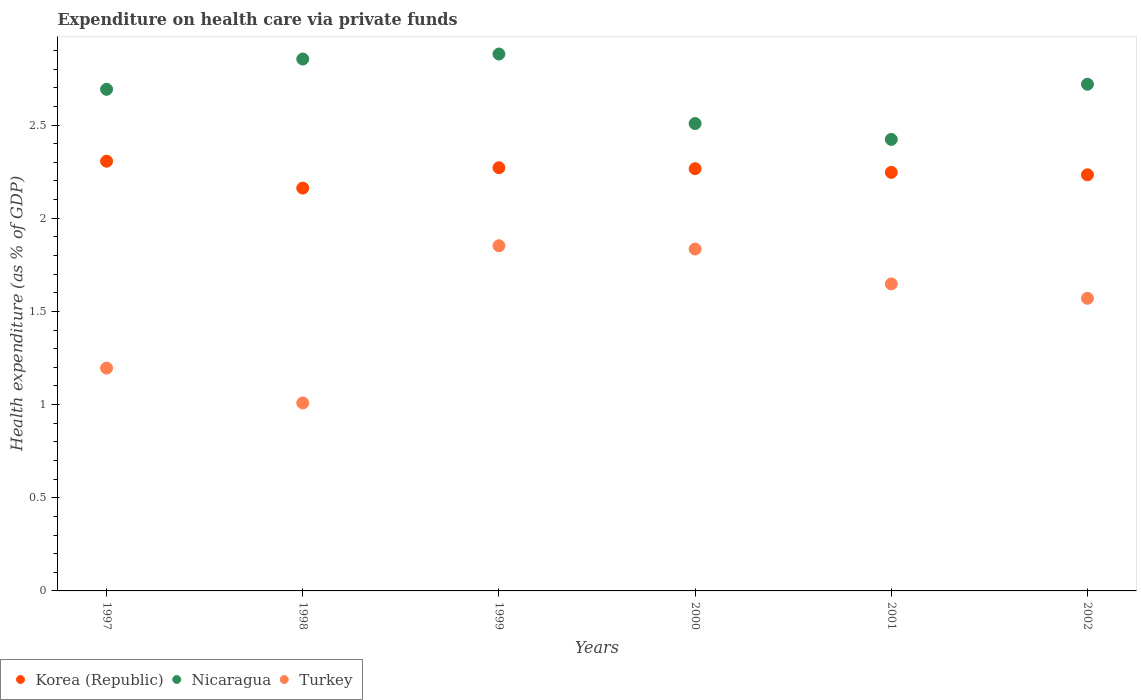Is the number of dotlines equal to the number of legend labels?
Offer a very short reply. Yes. What is the expenditure made on health care in Nicaragua in 2001?
Make the answer very short. 2.42. Across all years, what is the maximum expenditure made on health care in Korea (Republic)?
Your answer should be very brief. 2.31. Across all years, what is the minimum expenditure made on health care in Korea (Republic)?
Provide a succinct answer. 2.16. In which year was the expenditure made on health care in Turkey maximum?
Your answer should be very brief. 1999. What is the total expenditure made on health care in Nicaragua in the graph?
Make the answer very short. 16.08. What is the difference between the expenditure made on health care in Nicaragua in 1998 and that in 2002?
Give a very brief answer. 0.14. What is the difference between the expenditure made on health care in Korea (Republic) in 1999 and the expenditure made on health care in Turkey in 2000?
Your response must be concise. 0.44. What is the average expenditure made on health care in Turkey per year?
Make the answer very short. 1.52. In the year 1999, what is the difference between the expenditure made on health care in Korea (Republic) and expenditure made on health care in Turkey?
Your answer should be compact. 0.42. What is the ratio of the expenditure made on health care in Korea (Republic) in 1999 to that in 2002?
Your answer should be compact. 1.02. Is the expenditure made on health care in Nicaragua in 1999 less than that in 2000?
Your answer should be compact. No. Is the difference between the expenditure made on health care in Korea (Republic) in 2000 and 2001 greater than the difference between the expenditure made on health care in Turkey in 2000 and 2001?
Provide a short and direct response. No. What is the difference between the highest and the second highest expenditure made on health care in Turkey?
Offer a very short reply. 0.02. What is the difference between the highest and the lowest expenditure made on health care in Nicaragua?
Ensure brevity in your answer.  0.46. Is the sum of the expenditure made on health care in Nicaragua in 1997 and 2002 greater than the maximum expenditure made on health care in Turkey across all years?
Ensure brevity in your answer.  Yes. Is it the case that in every year, the sum of the expenditure made on health care in Korea (Republic) and expenditure made on health care in Nicaragua  is greater than the expenditure made on health care in Turkey?
Your answer should be compact. Yes. Does the expenditure made on health care in Nicaragua monotonically increase over the years?
Your response must be concise. No. How many dotlines are there?
Your answer should be very brief. 3. How many years are there in the graph?
Make the answer very short. 6. Does the graph contain any zero values?
Keep it short and to the point. No. Does the graph contain grids?
Give a very brief answer. No. What is the title of the graph?
Provide a short and direct response. Expenditure on health care via private funds. Does "Latin America(all income levels)" appear as one of the legend labels in the graph?
Provide a succinct answer. No. What is the label or title of the X-axis?
Provide a succinct answer. Years. What is the label or title of the Y-axis?
Offer a terse response. Health expenditure (as % of GDP). What is the Health expenditure (as % of GDP) in Korea (Republic) in 1997?
Offer a terse response. 2.31. What is the Health expenditure (as % of GDP) of Nicaragua in 1997?
Your answer should be compact. 2.69. What is the Health expenditure (as % of GDP) of Turkey in 1997?
Give a very brief answer. 1.2. What is the Health expenditure (as % of GDP) in Korea (Republic) in 1998?
Offer a very short reply. 2.16. What is the Health expenditure (as % of GDP) in Nicaragua in 1998?
Keep it short and to the point. 2.85. What is the Health expenditure (as % of GDP) in Turkey in 1998?
Keep it short and to the point. 1.01. What is the Health expenditure (as % of GDP) of Korea (Republic) in 1999?
Provide a short and direct response. 2.27. What is the Health expenditure (as % of GDP) in Nicaragua in 1999?
Your response must be concise. 2.88. What is the Health expenditure (as % of GDP) of Turkey in 1999?
Make the answer very short. 1.85. What is the Health expenditure (as % of GDP) in Korea (Republic) in 2000?
Keep it short and to the point. 2.27. What is the Health expenditure (as % of GDP) of Nicaragua in 2000?
Your response must be concise. 2.51. What is the Health expenditure (as % of GDP) in Turkey in 2000?
Provide a short and direct response. 1.83. What is the Health expenditure (as % of GDP) in Korea (Republic) in 2001?
Provide a short and direct response. 2.25. What is the Health expenditure (as % of GDP) in Nicaragua in 2001?
Provide a succinct answer. 2.42. What is the Health expenditure (as % of GDP) in Turkey in 2001?
Provide a short and direct response. 1.65. What is the Health expenditure (as % of GDP) in Korea (Republic) in 2002?
Make the answer very short. 2.23. What is the Health expenditure (as % of GDP) of Nicaragua in 2002?
Your answer should be very brief. 2.72. What is the Health expenditure (as % of GDP) of Turkey in 2002?
Make the answer very short. 1.57. Across all years, what is the maximum Health expenditure (as % of GDP) in Korea (Republic)?
Provide a succinct answer. 2.31. Across all years, what is the maximum Health expenditure (as % of GDP) in Nicaragua?
Your answer should be compact. 2.88. Across all years, what is the maximum Health expenditure (as % of GDP) of Turkey?
Your response must be concise. 1.85. Across all years, what is the minimum Health expenditure (as % of GDP) of Korea (Republic)?
Ensure brevity in your answer.  2.16. Across all years, what is the minimum Health expenditure (as % of GDP) of Nicaragua?
Offer a terse response. 2.42. Across all years, what is the minimum Health expenditure (as % of GDP) of Turkey?
Offer a terse response. 1.01. What is the total Health expenditure (as % of GDP) of Korea (Republic) in the graph?
Your response must be concise. 13.48. What is the total Health expenditure (as % of GDP) in Nicaragua in the graph?
Keep it short and to the point. 16.08. What is the total Health expenditure (as % of GDP) in Turkey in the graph?
Keep it short and to the point. 9.11. What is the difference between the Health expenditure (as % of GDP) of Korea (Republic) in 1997 and that in 1998?
Your answer should be compact. 0.14. What is the difference between the Health expenditure (as % of GDP) in Nicaragua in 1997 and that in 1998?
Offer a terse response. -0.16. What is the difference between the Health expenditure (as % of GDP) in Turkey in 1997 and that in 1998?
Make the answer very short. 0.19. What is the difference between the Health expenditure (as % of GDP) in Korea (Republic) in 1997 and that in 1999?
Provide a succinct answer. 0.04. What is the difference between the Health expenditure (as % of GDP) of Nicaragua in 1997 and that in 1999?
Your answer should be very brief. -0.19. What is the difference between the Health expenditure (as % of GDP) of Turkey in 1997 and that in 1999?
Offer a very short reply. -0.66. What is the difference between the Health expenditure (as % of GDP) in Korea (Republic) in 1997 and that in 2000?
Provide a short and direct response. 0.04. What is the difference between the Health expenditure (as % of GDP) in Nicaragua in 1997 and that in 2000?
Make the answer very short. 0.18. What is the difference between the Health expenditure (as % of GDP) of Turkey in 1997 and that in 2000?
Your response must be concise. -0.64. What is the difference between the Health expenditure (as % of GDP) of Korea (Republic) in 1997 and that in 2001?
Ensure brevity in your answer.  0.06. What is the difference between the Health expenditure (as % of GDP) of Nicaragua in 1997 and that in 2001?
Provide a short and direct response. 0.27. What is the difference between the Health expenditure (as % of GDP) in Turkey in 1997 and that in 2001?
Your answer should be very brief. -0.45. What is the difference between the Health expenditure (as % of GDP) of Korea (Republic) in 1997 and that in 2002?
Provide a short and direct response. 0.07. What is the difference between the Health expenditure (as % of GDP) in Nicaragua in 1997 and that in 2002?
Give a very brief answer. -0.03. What is the difference between the Health expenditure (as % of GDP) of Turkey in 1997 and that in 2002?
Your answer should be very brief. -0.37. What is the difference between the Health expenditure (as % of GDP) of Korea (Republic) in 1998 and that in 1999?
Ensure brevity in your answer.  -0.11. What is the difference between the Health expenditure (as % of GDP) in Nicaragua in 1998 and that in 1999?
Keep it short and to the point. -0.03. What is the difference between the Health expenditure (as % of GDP) of Turkey in 1998 and that in 1999?
Provide a succinct answer. -0.84. What is the difference between the Health expenditure (as % of GDP) in Korea (Republic) in 1998 and that in 2000?
Your answer should be compact. -0.1. What is the difference between the Health expenditure (as % of GDP) in Nicaragua in 1998 and that in 2000?
Make the answer very short. 0.35. What is the difference between the Health expenditure (as % of GDP) of Turkey in 1998 and that in 2000?
Keep it short and to the point. -0.83. What is the difference between the Health expenditure (as % of GDP) in Korea (Republic) in 1998 and that in 2001?
Your response must be concise. -0.08. What is the difference between the Health expenditure (as % of GDP) in Nicaragua in 1998 and that in 2001?
Provide a short and direct response. 0.43. What is the difference between the Health expenditure (as % of GDP) of Turkey in 1998 and that in 2001?
Give a very brief answer. -0.64. What is the difference between the Health expenditure (as % of GDP) of Korea (Republic) in 1998 and that in 2002?
Your answer should be very brief. -0.07. What is the difference between the Health expenditure (as % of GDP) in Nicaragua in 1998 and that in 2002?
Provide a short and direct response. 0.14. What is the difference between the Health expenditure (as % of GDP) of Turkey in 1998 and that in 2002?
Provide a succinct answer. -0.56. What is the difference between the Health expenditure (as % of GDP) of Korea (Republic) in 1999 and that in 2000?
Offer a terse response. 0.01. What is the difference between the Health expenditure (as % of GDP) of Nicaragua in 1999 and that in 2000?
Make the answer very short. 0.37. What is the difference between the Health expenditure (as % of GDP) of Turkey in 1999 and that in 2000?
Provide a succinct answer. 0.02. What is the difference between the Health expenditure (as % of GDP) of Korea (Republic) in 1999 and that in 2001?
Your response must be concise. 0.02. What is the difference between the Health expenditure (as % of GDP) of Nicaragua in 1999 and that in 2001?
Provide a short and direct response. 0.46. What is the difference between the Health expenditure (as % of GDP) in Turkey in 1999 and that in 2001?
Give a very brief answer. 0.2. What is the difference between the Health expenditure (as % of GDP) in Korea (Republic) in 1999 and that in 2002?
Make the answer very short. 0.04. What is the difference between the Health expenditure (as % of GDP) of Nicaragua in 1999 and that in 2002?
Provide a short and direct response. 0.16. What is the difference between the Health expenditure (as % of GDP) in Turkey in 1999 and that in 2002?
Your answer should be compact. 0.28. What is the difference between the Health expenditure (as % of GDP) in Korea (Republic) in 2000 and that in 2001?
Make the answer very short. 0.02. What is the difference between the Health expenditure (as % of GDP) in Nicaragua in 2000 and that in 2001?
Your answer should be very brief. 0.09. What is the difference between the Health expenditure (as % of GDP) of Turkey in 2000 and that in 2001?
Provide a short and direct response. 0.19. What is the difference between the Health expenditure (as % of GDP) of Korea (Republic) in 2000 and that in 2002?
Provide a short and direct response. 0.03. What is the difference between the Health expenditure (as % of GDP) in Nicaragua in 2000 and that in 2002?
Offer a very short reply. -0.21. What is the difference between the Health expenditure (as % of GDP) in Turkey in 2000 and that in 2002?
Provide a short and direct response. 0.26. What is the difference between the Health expenditure (as % of GDP) of Korea (Republic) in 2001 and that in 2002?
Ensure brevity in your answer.  0.01. What is the difference between the Health expenditure (as % of GDP) in Nicaragua in 2001 and that in 2002?
Offer a terse response. -0.3. What is the difference between the Health expenditure (as % of GDP) in Turkey in 2001 and that in 2002?
Your answer should be compact. 0.08. What is the difference between the Health expenditure (as % of GDP) of Korea (Republic) in 1997 and the Health expenditure (as % of GDP) of Nicaragua in 1998?
Your answer should be very brief. -0.55. What is the difference between the Health expenditure (as % of GDP) of Korea (Republic) in 1997 and the Health expenditure (as % of GDP) of Turkey in 1998?
Give a very brief answer. 1.3. What is the difference between the Health expenditure (as % of GDP) of Nicaragua in 1997 and the Health expenditure (as % of GDP) of Turkey in 1998?
Offer a very short reply. 1.68. What is the difference between the Health expenditure (as % of GDP) of Korea (Republic) in 1997 and the Health expenditure (as % of GDP) of Nicaragua in 1999?
Keep it short and to the point. -0.58. What is the difference between the Health expenditure (as % of GDP) in Korea (Republic) in 1997 and the Health expenditure (as % of GDP) in Turkey in 1999?
Provide a short and direct response. 0.45. What is the difference between the Health expenditure (as % of GDP) in Nicaragua in 1997 and the Health expenditure (as % of GDP) in Turkey in 1999?
Give a very brief answer. 0.84. What is the difference between the Health expenditure (as % of GDP) of Korea (Republic) in 1997 and the Health expenditure (as % of GDP) of Nicaragua in 2000?
Your answer should be compact. -0.2. What is the difference between the Health expenditure (as % of GDP) in Korea (Republic) in 1997 and the Health expenditure (as % of GDP) in Turkey in 2000?
Provide a short and direct response. 0.47. What is the difference between the Health expenditure (as % of GDP) of Nicaragua in 1997 and the Health expenditure (as % of GDP) of Turkey in 2000?
Your answer should be very brief. 0.86. What is the difference between the Health expenditure (as % of GDP) in Korea (Republic) in 1997 and the Health expenditure (as % of GDP) in Nicaragua in 2001?
Your answer should be very brief. -0.12. What is the difference between the Health expenditure (as % of GDP) of Korea (Republic) in 1997 and the Health expenditure (as % of GDP) of Turkey in 2001?
Offer a very short reply. 0.66. What is the difference between the Health expenditure (as % of GDP) of Nicaragua in 1997 and the Health expenditure (as % of GDP) of Turkey in 2001?
Make the answer very short. 1.04. What is the difference between the Health expenditure (as % of GDP) in Korea (Republic) in 1997 and the Health expenditure (as % of GDP) in Nicaragua in 2002?
Provide a short and direct response. -0.41. What is the difference between the Health expenditure (as % of GDP) in Korea (Republic) in 1997 and the Health expenditure (as % of GDP) in Turkey in 2002?
Your answer should be very brief. 0.74. What is the difference between the Health expenditure (as % of GDP) in Nicaragua in 1997 and the Health expenditure (as % of GDP) in Turkey in 2002?
Make the answer very short. 1.12. What is the difference between the Health expenditure (as % of GDP) in Korea (Republic) in 1998 and the Health expenditure (as % of GDP) in Nicaragua in 1999?
Ensure brevity in your answer.  -0.72. What is the difference between the Health expenditure (as % of GDP) of Korea (Republic) in 1998 and the Health expenditure (as % of GDP) of Turkey in 1999?
Provide a succinct answer. 0.31. What is the difference between the Health expenditure (as % of GDP) in Nicaragua in 1998 and the Health expenditure (as % of GDP) in Turkey in 1999?
Keep it short and to the point. 1. What is the difference between the Health expenditure (as % of GDP) of Korea (Republic) in 1998 and the Health expenditure (as % of GDP) of Nicaragua in 2000?
Ensure brevity in your answer.  -0.35. What is the difference between the Health expenditure (as % of GDP) of Korea (Republic) in 1998 and the Health expenditure (as % of GDP) of Turkey in 2000?
Offer a terse response. 0.33. What is the difference between the Health expenditure (as % of GDP) of Nicaragua in 1998 and the Health expenditure (as % of GDP) of Turkey in 2000?
Give a very brief answer. 1.02. What is the difference between the Health expenditure (as % of GDP) in Korea (Republic) in 1998 and the Health expenditure (as % of GDP) in Nicaragua in 2001?
Provide a short and direct response. -0.26. What is the difference between the Health expenditure (as % of GDP) of Korea (Republic) in 1998 and the Health expenditure (as % of GDP) of Turkey in 2001?
Keep it short and to the point. 0.51. What is the difference between the Health expenditure (as % of GDP) of Nicaragua in 1998 and the Health expenditure (as % of GDP) of Turkey in 2001?
Your answer should be very brief. 1.21. What is the difference between the Health expenditure (as % of GDP) in Korea (Republic) in 1998 and the Health expenditure (as % of GDP) in Nicaragua in 2002?
Provide a short and direct response. -0.56. What is the difference between the Health expenditure (as % of GDP) in Korea (Republic) in 1998 and the Health expenditure (as % of GDP) in Turkey in 2002?
Offer a terse response. 0.59. What is the difference between the Health expenditure (as % of GDP) in Nicaragua in 1998 and the Health expenditure (as % of GDP) in Turkey in 2002?
Your answer should be very brief. 1.28. What is the difference between the Health expenditure (as % of GDP) in Korea (Republic) in 1999 and the Health expenditure (as % of GDP) in Nicaragua in 2000?
Give a very brief answer. -0.24. What is the difference between the Health expenditure (as % of GDP) of Korea (Republic) in 1999 and the Health expenditure (as % of GDP) of Turkey in 2000?
Make the answer very short. 0.44. What is the difference between the Health expenditure (as % of GDP) of Nicaragua in 1999 and the Health expenditure (as % of GDP) of Turkey in 2000?
Ensure brevity in your answer.  1.05. What is the difference between the Health expenditure (as % of GDP) in Korea (Republic) in 1999 and the Health expenditure (as % of GDP) in Nicaragua in 2001?
Provide a short and direct response. -0.15. What is the difference between the Health expenditure (as % of GDP) of Korea (Republic) in 1999 and the Health expenditure (as % of GDP) of Turkey in 2001?
Provide a short and direct response. 0.62. What is the difference between the Health expenditure (as % of GDP) in Nicaragua in 1999 and the Health expenditure (as % of GDP) in Turkey in 2001?
Make the answer very short. 1.23. What is the difference between the Health expenditure (as % of GDP) of Korea (Republic) in 1999 and the Health expenditure (as % of GDP) of Nicaragua in 2002?
Give a very brief answer. -0.45. What is the difference between the Health expenditure (as % of GDP) in Korea (Republic) in 1999 and the Health expenditure (as % of GDP) in Turkey in 2002?
Keep it short and to the point. 0.7. What is the difference between the Health expenditure (as % of GDP) of Nicaragua in 1999 and the Health expenditure (as % of GDP) of Turkey in 2002?
Your response must be concise. 1.31. What is the difference between the Health expenditure (as % of GDP) of Korea (Republic) in 2000 and the Health expenditure (as % of GDP) of Nicaragua in 2001?
Give a very brief answer. -0.16. What is the difference between the Health expenditure (as % of GDP) of Korea (Republic) in 2000 and the Health expenditure (as % of GDP) of Turkey in 2001?
Provide a succinct answer. 0.62. What is the difference between the Health expenditure (as % of GDP) of Nicaragua in 2000 and the Health expenditure (as % of GDP) of Turkey in 2001?
Ensure brevity in your answer.  0.86. What is the difference between the Health expenditure (as % of GDP) in Korea (Republic) in 2000 and the Health expenditure (as % of GDP) in Nicaragua in 2002?
Offer a very short reply. -0.45. What is the difference between the Health expenditure (as % of GDP) of Korea (Republic) in 2000 and the Health expenditure (as % of GDP) of Turkey in 2002?
Offer a very short reply. 0.7. What is the difference between the Health expenditure (as % of GDP) of Nicaragua in 2000 and the Health expenditure (as % of GDP) of Turkey in 2002?
Provide a short and direct response. 0.94. What is the difference between the Health expenditure (as % of GDP) in Korea (Republic) in 2001 and the Health expenditure (as % of GDP) in Nicaragua in 2002?
Give a very brief answer. -0.47. What is the difference between the Health expenditure (as % of GDP) of Korea (Republic) in 2001 and the Health expenditure (as % of GDP) of Turkey in 2002?
Your answer should be compact. 0.68. What is the difference between the Health expenditure (as % of GDP) of Nicaragua in 2001 and the Health expenditure (as % of GDP) of Turkey in 2002?
Provide a succinct answer. 0.85. What is the average Health expenditure (as % of GDP) in Korea (Republic) per year?
Offer a terse response. 2.25. What is the average Health expenditure (as % of GDP) in Nicaragua per year?
Give a very brief answer. 2.68. What is the average Health expenditure (as % of GDP) of Turkey per year?
Your answer should be very brief. 1.52. In the year 1997, what is the difference between the Health expenditure (as % of GDP) of Korea (Republic) and Health expenditure (as % of GDP) of Nicaragua?
Your answer should be compact. -0.39. In the year 1997, what is the difference between the Health expenditure (as % of GDP) in Korea (Republic) and Health expenditure (as % of GDP) in Turkey?
Make the answer very short. 1.11. In the year 1997, what is the difference between the Health expenditure (as % of GDP) of Nicaragua and Health expenditure (as % of GDP) of Turkey?
Keep it short and to the point. 1.5. In the year 1998, what is the difference between the Health expenditure (as % of GDP) in Korea (Republic) and Health expenditure (as % of GDP) in Nicaragua?
Your answer should be very brief. -0.69. In the year 1998, what is the difference between the Health expenditure (as % of GDP) in Korea (Republic) and Health expenditure (as % of GDP) in Turkey?
Offer a very short reply. 1.15. In the year 1998, what is the difference between the Health expenditure (as % of GDP) in Nicaragua and Health expenditure (as % of GDP) in Turkey?
Your response must be concise. 1.85. In the year 1999, what is the difference between the Health expenditure (as % of GDP) of Korea (Republic) and Health expenditure (as % of GDP) of Nicaragua?
Keep it short and to the point. -0.61. In the year 1999, what is the difference between the Health expenditure (as % of GDP) in Korea (Republic) and Health expenditure (as % of GDP) in Turkey?
Your response must be concise. 0.42. In the year 1999, what is the difference between the Health expenditure (as % of GDP) in Nicaragua and Health expenditure (as % of GDP) in Turkey?
Provide a succinct answer. 1.03. In the year 2000, what is the difference between the Health expenditure (as % of GDP) in Korea (Republic) and Health expenditure (as % of GDP) in Nicaragua?
Give a very brief answer. -0.24. In the year 2000, what is the difference between the Health expenditure (as % of GDP) in Korea (Republic) and Health expenditure (as % of GDP) in Turkey?
Keep it short and to the point. 0.43. In the year 2000, what is the difference between the Health expenditure (as % of GDP) of Nicaragua and Health expenditure (as % of GDP) of Turkey?
Your answer should be very brief. 0.67. In the year 2001, what is the difference between the Health expenditure (as % of GDP) of Korea (Republic) and Health expenditure (as % of GDP) of Nicaragua?
Offer a very short reply. -0.18. In the year 2001, what is the difference between the Health expenditure (as % of GDP) in Korea (Republic) and Health expenditure (as % of GDP) in Turkey?
Offer a very short reply. 0.6. In the year 2001, what is the difference between the Health expenditure (as % of GDP) in Nicaragua and Health expenditure (as % of GDP) in Turkey?
Provide a short and direct response. 0.78. In the year 2002, what is the difference between the Health expenditure (as % of GDP) of Korea (Republic) and Health expenditure (as % of GDP) of Nicaragua?
Your response must be concise. -0.49. In the year 2002, what is the difference between the Health expenditure (as % of GDP) in Korea (Republic) and Health expenditure (as % of GDP) in Turkey?
Your answer should be very brief. 0.66. In the year 2002, what is the difference between the Health expenditure (as % of GDP) in Nicaragua and Health expenditure (as % of GDP) in Turkey?
Give a very brief answer. 1.15. What is the ratio of the Health expenditure (as % of GDP) of Korea (Republic) in 1997 to that in 1998?
Your answer should be compact. 1.07. What is the ratio of the Health expenditure (as % of GDP) in Nicaragua in 1997 to that in 1998?
Offer a terse response. 0.94. What is the ratio of the Health expenditure (as % of GDP) in Turkey in 1997 to that in 1998?
Ensure brevity in your answer.  1.19. What is the ratio of the Health expenditure (as % of GDP) in Korea (Republic) in 1997 to that in 1999?
Your answer should be compact. 1.02. What is the ratio of the Health expenditure (as % of GDP) of Nicaragua in 1997 to that in 1999?
Provide a short and direct response. 0.93. What is the ratio of the Health expenditure (as % of GDP) of Turkey in 1997 to that in 1999?
Provide a succinct answer. 0.65. What is the ratio of the Health expenditure (as % of GDP) in Korea (Republic) in 1997 to that in 2000?
Offer a terse response. 1.02. What is the ratio of the Health expenditure (as % of GDP) of Nicaragua in 1997 to that in 2000?
Offer a very short reply. 1.07. What is the ratio of the Health expenditure (as % of GDP) in Turkey in 1997 to that in 2000?
Keep it short and to the point. 0.65. What is the ratio of the Health expenditure (as % of GDP) in Korea (Republic) in 1997 to that in 2001?
Give a very brief answer. 1.03. What is the ratio of the Health expenditure (as % of GDP) in Nicaragua in 1997 to that in 2001?
Give a very brief answer. 1.11. What is the ratio of the Health expenditure (as % of GDP) of Turkey in 1997 to that in 2001?
Offer a very short reply. 0.73. What is the ratio of the Health expenditure (as % of GDP) in Korea (Republic) in 1997 to that in 2002?
Keep it short and to the point. 1.03. What is the ratio of the Health expenditure (as % of GDP) in Nicaragua in 1997 to that in 2002?
Offer a very short reply. 0.99. What is the ratio of the Health expenditure (as % of GDP) of Turkey in 1997 to that in 2002?
Offer a very short reply. 0.76. What is the ratio of the Health expenditure (as % of GDP) in Korea (Republic) in 1998 to that in 1999?
Give a very brief answer. 0.95. What is the ratio of the Health expenditure (as % of GDP) in Nicaragua in 1998 to that in 1999?
Your answer should be compact. 0.99. What is the ratio of the Health expenditure (as % of GDP) in Turkey in 1998 to that in 1999?
Offer a very short reply. 0.54. What is the ratio of the Health expenditure (as % of GDP) in Korea (Republic) in 1998 to that in 2000?
Offer a terse response. 0.95. What is the ratio of the Health expenditure (as % of GDP) of Nicaragua in 1998 to that in 2000?
Provide a short and direct response. 1.14. What is the ratio of the Health expenditure (as % of GDP) of Turkey in 1998 to that in 2000?
Your answer should be compact. 0.55. What is the ratio of the Health expenditure (as % of GDP) of Korea (Republic) in 1998 to that in 2001?
Your answer should be compact. 0.96. What is the ratio of the Health expenditure (as % of GDP) in Nicaragua in 1998 to that in 2001?
Give a very brief answer. 1.18. What is the ratio of the Health expenditure (as % of GDP) in Turkey in 1998 to that in 2001?
Offer a very short reply. 0.61. What is the ratio of the Health expenditure (as % of GDP) in Korea (Republic) in 1998 to that in 2002?
Make the answer very short. 0.97. What is the ratio of the Health expenditure (as % of GDP) in Nicaragua in 1998 to that in 2002?
Your answer should be very brief. 1.05. What is the ratio of the Health expenditure (as % of GDP) in Turkey in 1998 to that in 2002?
Keep it short and to the point. 0.64. What is the ratio of the Health expenditure (as % of GDP) in Korea (Republic) in 1999 to that in 2000?
Your response must be concise. 1. What is the ratio of the Health expenditure (as % of GDP) in Nicaragua in 1999 to that in 2000?
Your answer should be very brief. 1.15. What is the ratio of the Health expenditure (as % of GDP) in Turkey in 1999 to that in 2000?
Give a very brief answer. 1.01. What is the ratio of the Health expenditure (as % of GDP) of Korea (Republic) in 1999 to that in 2001?
Give a very brief answer. 1.01. What is the ratio of the Health expenditure (as % of GDP) of Nicaragua in 1999 to that in 2001?
Provide a short and direct response. 1.19. What is the ratio of the Health expenditure (as % of GDP) in Turkey in 1999 to that in 2001?
Provide a succinct answer. 1.12. What is the ratio of the Health expenditure (as % of GDP) of Nicaragua in 1999 to that in 2002?
Give a very brief answer. 1.06. What is the ratio of the Health expenditure (as % of GDP) in Turkey in 1999 to that in 2002?
Your answer should be compact. 1.18. What is the ratio of the Health expenditure (as % of GDP) in Korea (Republic) in 2000 to that in 2001?
Ensure brevity in your answer.  1.01. What is the ratio of the Health expenditure (as % of GDP) of Nicaragua in 2000 to that in 2001?
Provide a succinct answer. 1.04. What is the ratio of the Health expenditure (as % of GDP) of Turkey in 2000 to that in 2001?
Provide a short and direct response. 1.11. What is the ratio of the Health expenditure (as % of GDP) of Korea (Republic) in 2000 to that in 2002?
Provide a short and direct response. 1.01. What is the ratio of the Health expenditure (as % of GDP) in Nicaragua in 2000 to that in 2002?
Provide a short and direct response. 0.92. What is the ratio of the Health expenditure (as % of GDP) of Turkey in 2000 to that in 2002?
Your answer should be very brief. 1.17. What is the ratio of the Health expenditure (as % of GDP) in Korea (Republic) in 2001 to that in 2002?
Provide a short and direct response. 1.01. What is the ratio of the Health expenditure (as % of GDP) in Nicaragua in 2001 to that in 2002?
Offer a very short reply. 0.89. What is the ratio of the Health expenditure (as % of GDP) in Turkey in 2001 to that in 2002?
Offer a very short reply. 1.05. What is the difference between the highest and the second highest Health expenditure (as % of GDP) in Korea (Republic)?
Offer a very short reply. 0.04. What is the difference between the highest and the second highest Health expenditure (as % of GDP) of Nicaragua?
Your answer should be very brief. 0.03. What is the difference between the highest and the second highest Health expenditure (as % of GDP) in Turkey?
Offer a very short reply. 0.02. What is the difference between the highest and the lowest Health expenditure (as % of GDP) in Korea (Republic)?
Your response must be concise. 0.14. What is the difference between the highest and the lowest Health expenditure (as % of GDP) of Nicaragua?
Your answer should be compact. 0.46. What is the difference between the highest and the lowest Health expenditure (as % of GDP) of Turkey?
Offer a very short reply. 0.84. 